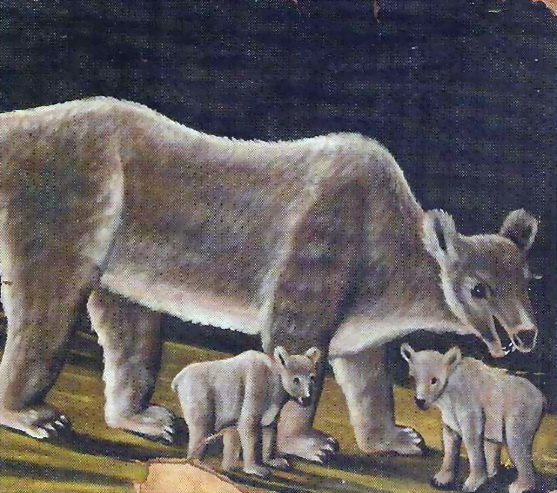How might this scene be different if it took place during winter? In winter, the scene would transform into a snowy wonderland. The forest floor would be covered in a blanket of white, with delicate, sparkling snowflakes floating gently down from the sky. The mother bear's fur would be slightly frosted, and her breath would form visible puffs in the cold air. The cubs would be frolicking in the snow, their playful antics kicking up flurries around them. The trees, now bare of leaves, would stand tall and stately, their branches clad in a thin layer of ice. The river would be partly frozen, with patches of clear water reflecting the pale winter sun. Despite the cold, the mother's protective presence and the cubs' boundless energy would still convey warmth and life in this tranquil, wintry scene.  What could be a short but realistic scenario for this image? The mother bear is taking her cubs for a walk through the forest, teaching them how to find food and stay safe. They stop at a spot where the sunlight breaks through the canopy, and the cubs, curious and energetic, stand on their hind legs to get a better view of their surroundings. 